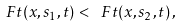Convert formula to latex. <formula><loc_0><loc_0><loc_500><loc_500>\ F t ( x , s _ { 1 } , t ) < \ F t ( x , s _ { 2 } , t ) \, ,</formula> 